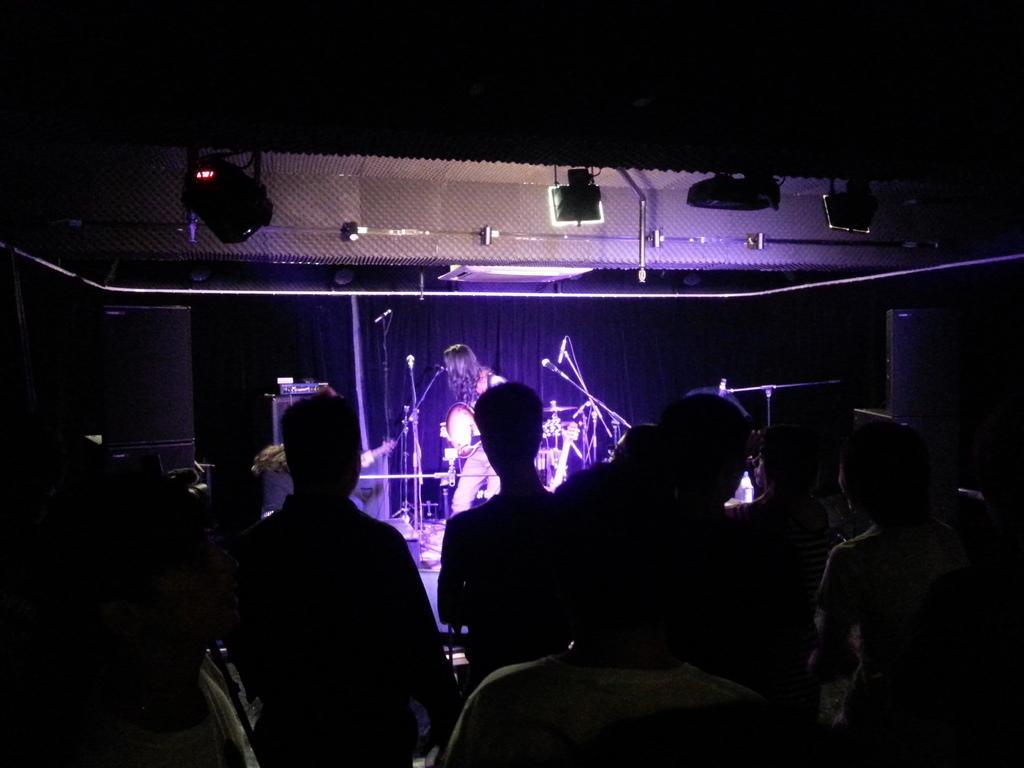Describe this image in one or two sentences. In this image I can see number of people are standing. In the background I can see number of mics, a drum set, few speakers and on the top side of this image I can see few lights. I can also see this image is little bit in dark. 